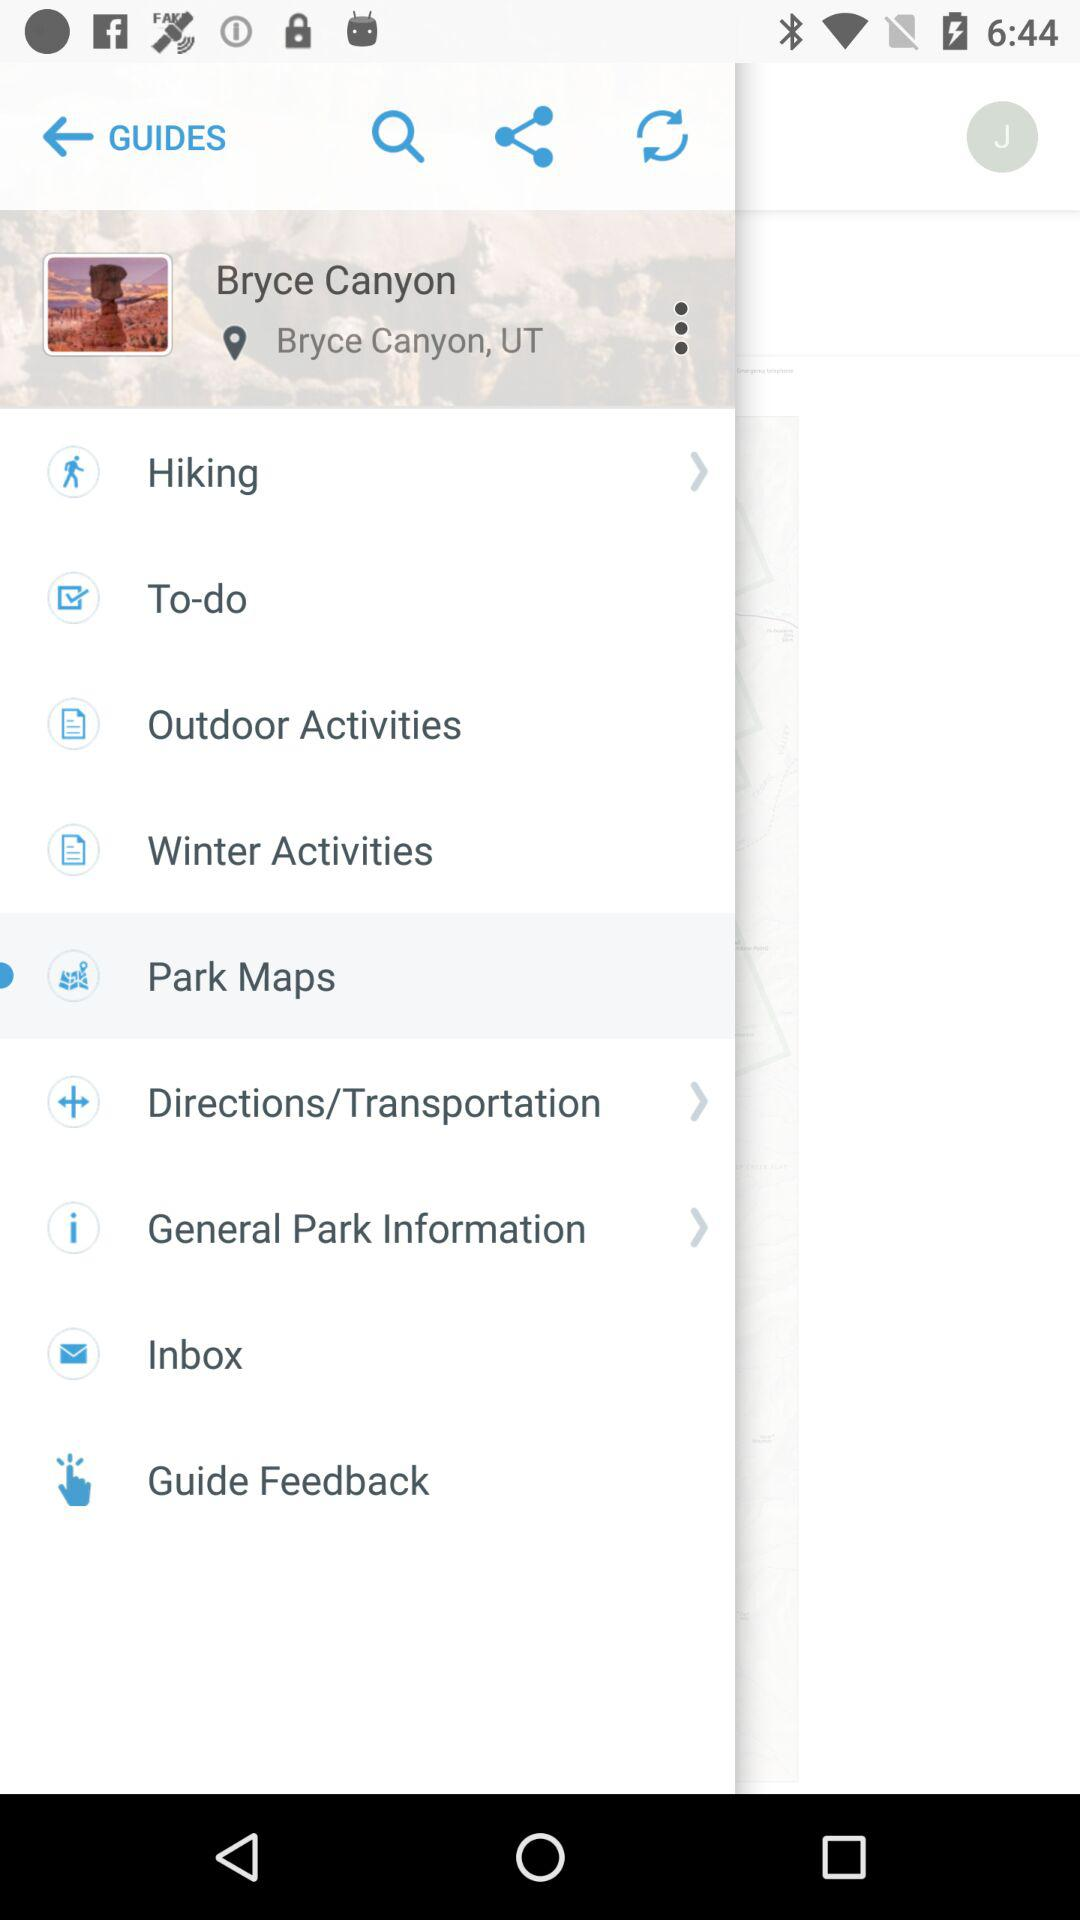What is the name of the canyon? The name is Bryce Canyon. 